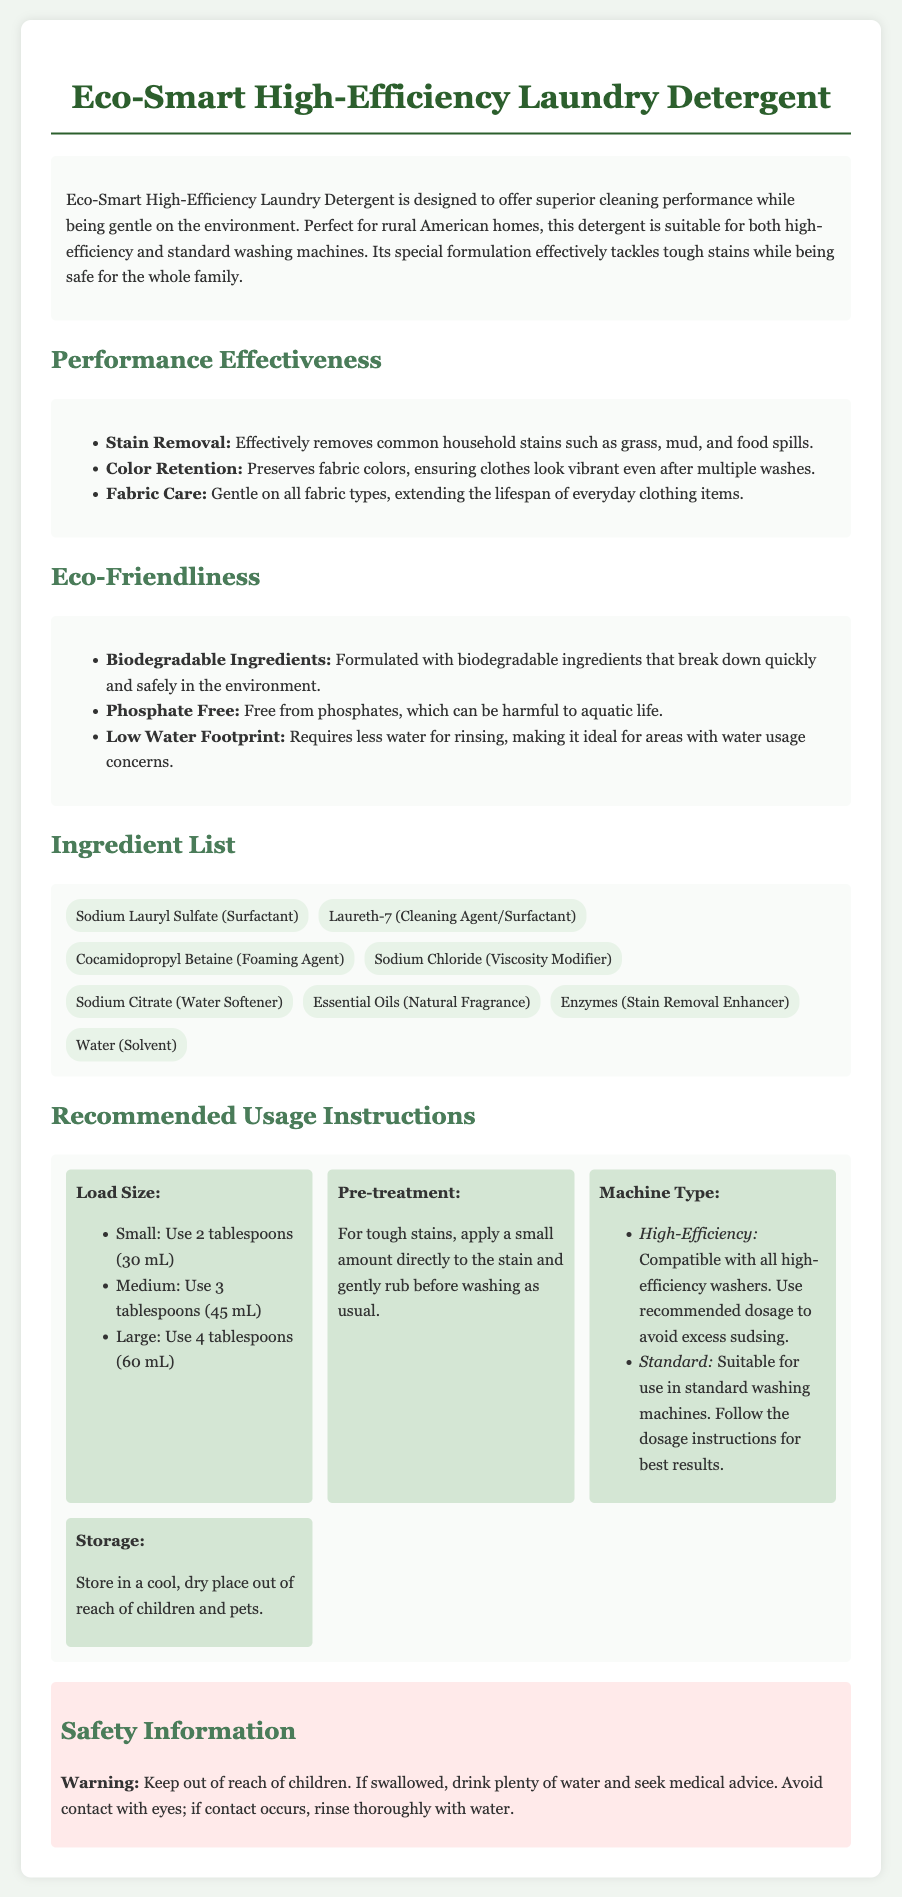What type of washing machines is the detergent suitable for? The document states that the detergent is suitable for both high-efficiency and standard washing machines.
Answer: High-efficiency and standard washing machines What is the recommended dosage for a medium load? The document specifies the dosage for different load sizes, indicating that a medium load requires 3 tablespoons.
Answer: 3 tablespoons (45 mL) What ingredients are considered biodegradable? The document explicitly mentions that the detergent is formulated with biodegradable ingredients, but does not list specific ones in that context.
Answer: All ingredients How many tablespoons should be used for a large load? The document specifies that for a large load, 4 tablespoons should be used.
Answer: 4 tablespoons (60 mL) What is the purpose of Sodium Citrate in the ingredient list? The document categorizes Sodium Citrate as a water softener in the ingredient list.
Answer: Water Softener Does the detergent contain phosphates? The document clearly states that the detergent is free from phosphates, which can be harmful to aquatic life.
Answer: Phosphate free What natural ingredient is used for fragrance? The ingredient list includes essential oils as a natural fragrance component.
Answer: Essential Oils What should be done for tough stains? The document recommends applying a small amount directly to the stain and gently rubbing before washing.
Answer: Apply a small amount directly to the stain What warning is provided regarding safety? The safety information warns to keep the detergent out of reach of children and advises on what to do if swallowed.
Answer: Keep out of reach of children 